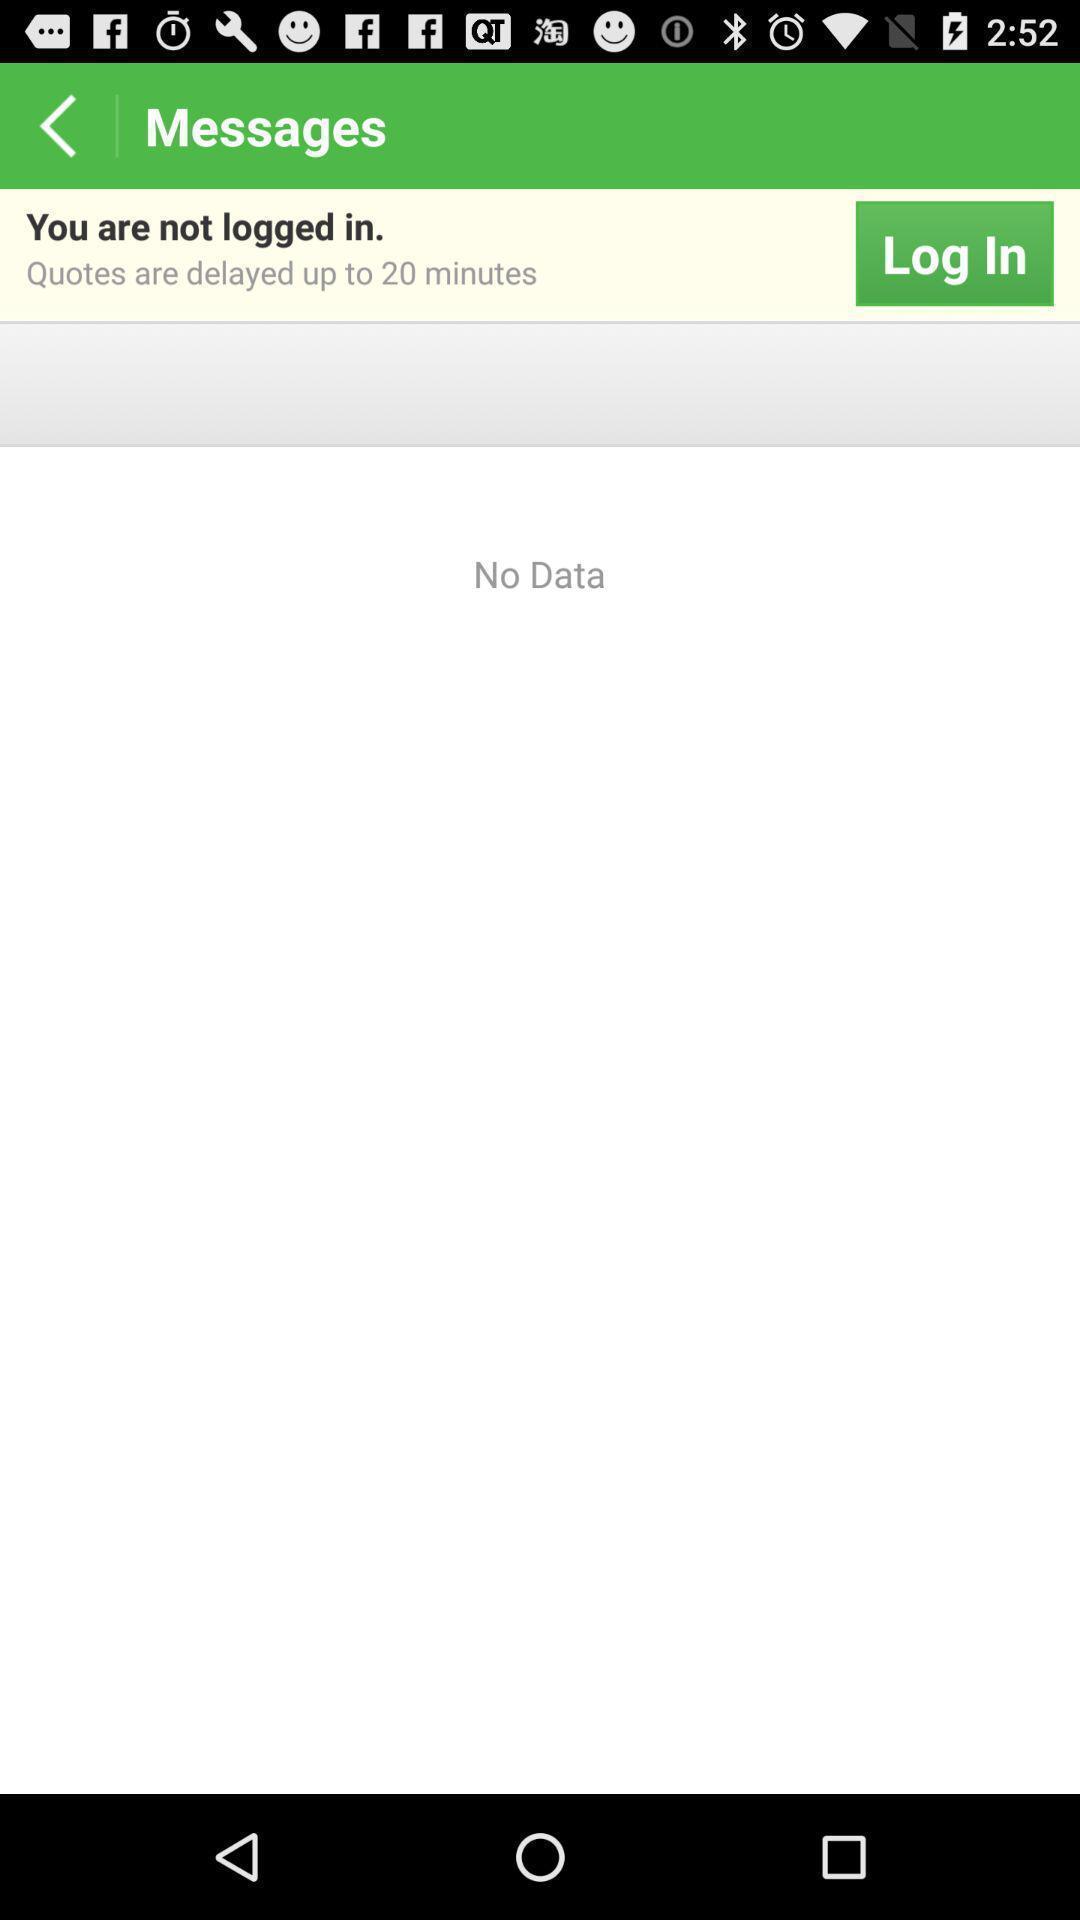Describe the content in this image. Screen showing messages. 